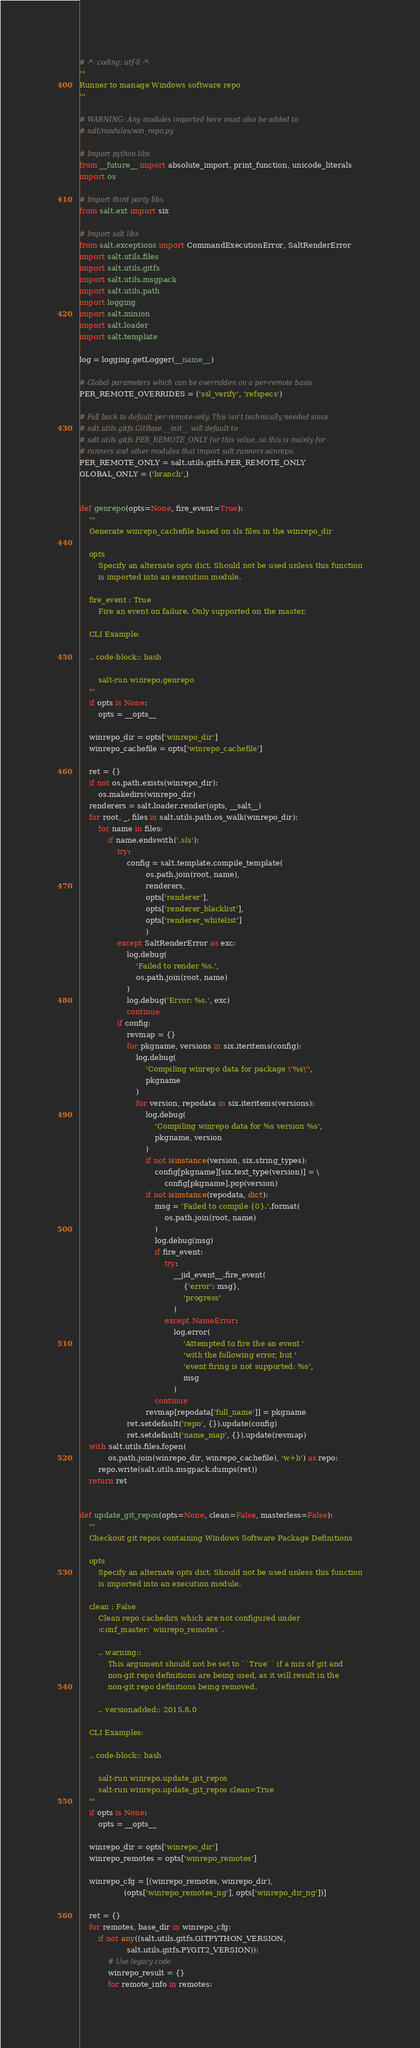Convert code to text. <code><loc_0><loc_0><loc_500><loc_500><_Python_># -*- coding: utf-8 -*-
'''
Runner to manage Windows software repo
'''

# WARNING: Any modules imported here must also be added to
# salt/modules/win_repo.py

# Import python libs
from __future__ import absolute_import, print_function, unicode_literals
import os

# Import third party libs
from salt.ext import six

# Import salt libs
from salt.exceptions import CommandExecutionError, SaltRenderError
import salt.utils.files
import salt.utils.gitfs
import salt.utils.msgpack
import salt.utils.path
import logging
import salt.minion
import salt.loader
import salt.template

log = logging.getLogger(__name__)

# Global parameters which can be overridden on a per-remote basis
PER_REMOTE_OVERRIDES = ('ssl_verify', 'refspecs')

# Fall back to default per-remote-only. This isn't technically needed since
# salt.utils.gitfs.GitBase.__init__ will default to
# salt.utils.gitfs.PER_REMOTE_ONLY for this value, so this is mainly for
# runners and other modules that import salt.runners.winrepo.
PER_REMOTE_ONLY = salt.utils.gitfs.PER_REMOTE_ONLY
GLOBAL_ONLY = ('branch',)


def genrepo(opts=None, fire_event=True):
    '''
    Generate winrepo_cachefile based on sls files in the winrepo_dir

    opts
        Specify an alternate opts dict. Should not be used unless this function
        is imported into an execution module.

    fire_event : True
        Fire an event on failure. Only supported on the master.

    CLI Example:

    .. code-block:: bash

        salt-run winrepo.genrepo
    '''
    if opts is None:
        opts = __opts__

    winrepo_dir = opts['winrepo_dir']
    winrepo_cachefile = opts['winrepo_cachefile']

    ret = {}
    if not os.path.exists(winrepo_dir):
        os.makedirs(winrepo_dir)
    renderers = salt.loader.render(opts, __salt__)
    for root, _, files in salt.utils.path.os_walk(winrepo_dir):
        for name in files:
            if name.endswith('.sls'):
                try:
                    config = salt.template.compile_template(
                            os.path.join(root, name),
                            renderers,
                            opts['renderer'],
                            opts['renderer_blacklist'],
                            opts['renderer_whitelist']
                            )
                except SaltRenderError as exc:
                    log.debug(
                        'Failed to render %s.',
                        os.path.join(root, name)
                    )
                    log.debug('Error: %s.', exc)
                    continue
                if config:
                    revmap = {}
                    for pkgname, versions in six.iteritems(config):
                        log.debug(
                            'Compiling winrepo data for package \'%s\'',
                            pkgname
                        )
                        for version, repodata in six.iteritems(versions):
                            log.debug(
                                'Compiling winrepo data for %s version %s',
                                pkgname, version
                            )
                            if not isinstance(version, six.string_types):
                                config[pkgname][six.text_type(version)] = \
                                    config[pkgname].pop(version)
                            if not isinstance(repodata, dict):
                                msg = 'Failed to compile {0}.'.format(
                                    os.path.join(root, name)
                                )
                                log.debug(msg)
                                if fire_event:
                                    try:
                                        __jid_event__.fire_event(
                                            {'error': msg},
                                            'progress'
                                        )
                                    except NameError:
                                        log.error(
                                            'Attempted to fire the an event '
                                            'with the following error, but '
                                            'event firing is not supported: %s',
                                            msg
                                        )
                                continue
                            revmap[repodata['full_name']] = pkgname
                    ret.setdefault('repo', {}).update(config)
                    ret.setdefault('name_map', {}).update(revmap)
    with salt.utils.files.fopen(
            os.path.join(winrepo_dir, winrepo_cachefile), 'w+b') as repo:
        repo.write(salt.utils.msgpack.dumps(ret))
    return ret


def update_git_repos(opts=None, clean=False, masterless=False):
    '''
    Checkout git repos containing Windows Software Package Definitions

    opts
        Specify an alternate opts dict. Should not be used unless this function
        is imported into an execution module.

    clean : False
        Clean repo cachedirs which are not configured under
        :conf_master:`winrepo_remotes`.

        .. warning::
            This argument should not be set to ``True`` if a mix of git and
            non-git repo definitions are being used, as it will result in the
            non-git repo definitions being removed.

        .. versionadded:: 2015.8.0

    CLI Examples:

    .. code-block:: bash

        salt-run winrepo.update_git_repos
        salt-run winrepo.update_git_repos clean=True
    '''
    if opts is None:
        opts = __opts__

    winrepo_dir = opts['winrepo_dir']
    winrepo_remotes = opts['winrepo_remotes']

    winrepo_cfg = [(winrepo_remotes, winrepo_dir),
                   (opts['winrepo_remotes_ng'], opts['winrepo_dir_ng'])]

    ret = {}
    for remotes, base_dir in winrepo_cfg:
        if not any((salt.utils.gitfs.GITPYTHON_VERSION,
                    salt.utils.gitfs.PYGIT2_VERSION)):
            # Use legacy code
            winrepo_result = {}
            for remote_info in remotes:</code> 